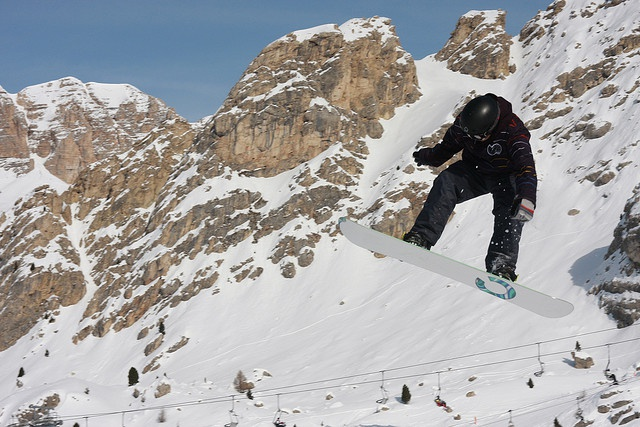Describe the objects in this image and their specific colors. I can see people in gray, black, darkgray, and lightgray tones, snowboard in gray, darkgray, lightgray, and teal tones, people in gray, black, and darkgray tones, and people in gray and black tones in this image. 